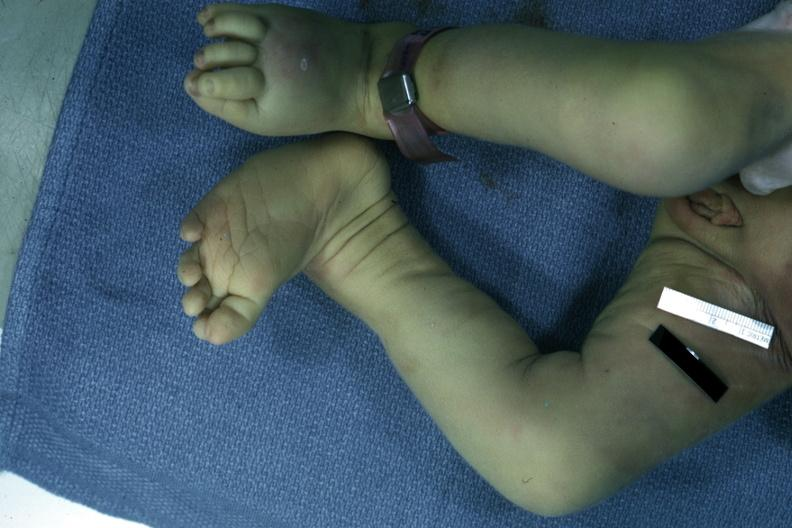re extremities present?
Answer the question using a single word or phrase. Yes 